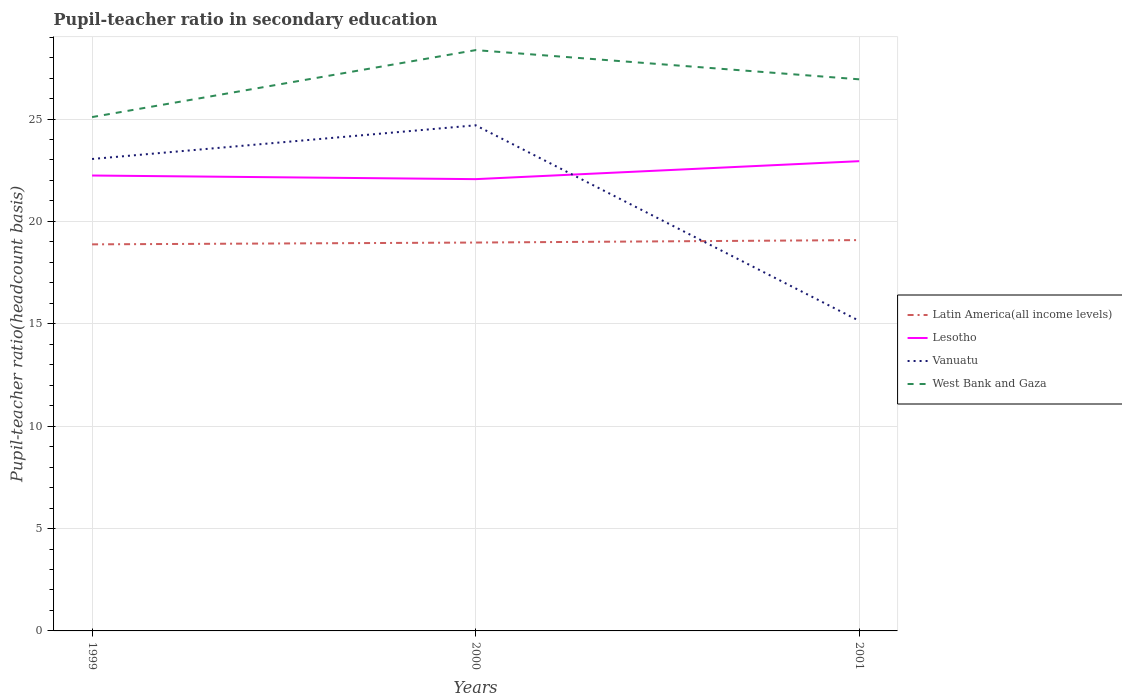Is the number of lines equal to the number of legend labels?
Offer a very short reply. Yes. Across all years, what is the maximum pupil-teacher ratio in secondary education in Latin America(all income levels)?
Your answer should be compact. 18.88. In which year was the pupil-teacher ratio in secondary education in Vanuatu maximum?
Offer a terse response. 2001. What is the total pupil-teacher ratio in secondary education in West Bank and Gaza in the graph?
Give a very brief answer. 1.43. What is the difference between the highest and the second highest pupil-teacher ratio in secondary education in Vanuatu?
Offer a very short reply. 9.55. How many lines are there?
Your answer should be compact. 4. How are the legend labels stacked?
Provide a succinct answer. Vertical. What is the title of the graph?
Ensure brevity in your answer.  Pupil-teacher ratio in secondary education. What is the label or title of the Y-axis?
Your response must be concise. Pupil-teacher ratio(headcount basis). What is the Pupil-teacher ratio(headcount basis) of Latin America(all income levels) in 1999?
Your answer should be very brief. 18.88. What is the Pupil-teacher ratio(headcount basis) in Lesotho in 1999?
Provide a short and direct response. 22.24. What is the Pupil-teacher ratio(headcount basis) in Vanuatu in 1999?
Make the answer very short. 23.05. What is the Pupil-teacher ratio(headcount basis) in West Bank and Gaza in 1999?
Keep it short and to the point. 25.1. What is the Pupil-teacher ratio(headcount basis) of Latin America(all income levels) in 2000?
Your answer should be compact. 18.97. What is the Pupil-teacher ratio(headcount basis) in Lesotho in 2000?
Give a very brief answer. 22.06. What is the Pupil-teacher ratio(headcount basis) in Vanuatu in 2000?
Ensure brevity in your answer.  24.7. What is the Pupil-teacher ratio(headcount basis) of West Bank and Gaza in 2000?
Your answer should be very brief. 28.37. What is the Pupil-teacher ratio(headcount basis) in Latin America(all income levels) in 2001?
Your answer should be compact. 19.09. What is the Pupil-teacher ratio(headcount basis) in Lesotho in 2001?
Your answer should be compact. 22.94. What is the Pupil-teacher ratio(headcount basis) of Vanuatu in 2001?
Keep it short and to the point. 15.14. What is the Pupil-teacher ratio(headcount basis) in West Bank and Gaza in 2001?
Offer a very short reply. 26.94. Across all years, what is the maximum Pupil-teacher ratio(headcount basis) in Latin America(all income levels)?
Your answer should be very brief. 19.09. Across all years, what is the maximum Pupil-teacher ratio(headcount basis) in Lesotho?
Provide a short and direct response. 22.94. Across all years, what is the maximum Pupil-teacher ratio(headcount basis) of Vanuatu?
Ensure brevity in your answer.  24.7. Across all years, what is the maximum Pupil-teacher ratio(headcount basis) of West Bank and Gaza?
Keep it short and to the point. 28.37. Across all years, what is the minimum Pupil-teacher ratio(headcount basis) in Latin America(all income levels)?
Provide a short and direct response. 18.88. Across all years, what is the minimum Pupil-teacher ratio(headcount basis) in Lesotho?
Provide a short and direct response. 22.06. Across all years, what is the minimum Pupil-teacher ratio(headcount basis) in Vanuatu?
Your answer should be very brief. 15.14. Across all years, what is the minimum Pupil-teacher ratio(headcount basis) in West Bank and Gaza?
Offer a very short reply. 25.1. What is the total Pupil-teacher ratio(headcount basis) of Latin America(all income levels) in the graph?
Your response must be concise. 56.94. What is the total Pupil-teacher ratio(headcount basis) in Lesotho in the graph?
Your answer should be very brief. 67.25. What is the total Pupil-teacher ratio(headcount basis) of Vanuatu in the graph?
Your response must be concise. 62.89. What is the total Pupil-teacher ratio(headcount basis) of West Bank and Gaza in the graph?
Your answer should be compact. 80.4. What is the difference between the Pupil-teacher ratio(headcount basis) of Latin America(all income levels) in 1999 and that in 2000?
Make the answer very short. -0.09. What is the difference between the Pupil-teacher ratio(headcount basis) in Lesotho in 1999 and that in 2000?
Your answer should be compact. 0.18. What is the difference between the Pupil-teacher ratio(headcount basis) in Vanuatu in 1999 and that in 2000?
Make the answer very short. -1.65. What is the difference between the Pupil-teacher ratio(headcount basis) in West Bank and Gaza in 1999 and that in 2000?
Offer a very short reply. -3.27. What is the difference between the Pupil-teacher ratio(headcount basis) in Latin America(all income levels) in 1999 and that in 2001?
Provide a succinct answer. -0.21. What is the difference between the Pupil-teacher ratio(headcount basis) of Lesotho in 1999 and that in 2001?
Offer a very short reply. -0.7. What is the difference between the Pupil-teacher ratio(headcount basis) in Vanuatu in 1999 and that in 2001?
Provide a succinct answer. 7.9. What is the difference between the Pupil-teacher ratio(headcount basis) in West Bank and Gaza in 1999 and that in 2001?
Your answer should be compact. -1.84. What is the difference between the Pupil-teacher ratio(headcount basis) of Latin America(all income levels) in 2000 and that in 2001?
Keep it short and to the point. -0.12. What is the difference between the Pupil-teacher ratio(headcount basis) in Lesotho in 2000 and that in 2001?
Offer a very short reply. -0.88. What is the difference between the Pupil-teacher ratio(headcount basis) of Vanuatu in 2000 and that in 2001?
Keep it short and to the point. 9.55. What is the difference between the Pupil-teacher ratio(headcount basis) of West Bank and Gaza in 2000 and that in 2001?
Offer a terse response. 1.43. What is the difference between the Pupil-teacher ratio(headcount basis) in Latin America(all income levels) in 1999 and the Pupil-teacher ratio(headcount basis) in Lesotho in 2000?
Give a very brief answer. -3.18. What is the difference between the Pupil-teacher ratio(headcount basis) in Latin America(all income levels) in 1999 and the Pupil-teacher ratio(headcount basis) in Vanuatu in 2000?
Your response must be concise. -5.82. What is the difference between the Pupil-teacher ratio(headcount basis) in Latin America(all income levels) in 1999 and the Pupil-teacher ratio(headcount basis) in West Bank and Gaza in 2000?
Make the answer very short. -9.49. What is the difference between the Pupil-teacher ratio(headcount basis) in Lesotho in 1999 and the Pupil-teacher ratio(headcount basis) in Vanuatu in 2000?
Your response must be concise. -2.45. What is the difference between the Pupil-teacher ratio(headcount basis) in Lesotho in 1999 and the Pupil-teacher ratio(headcount basis) in West Bank and Gaza in 2000?
Provide a short and direct response. -6.12. What is the difference between the Pupil-teacher ratio(headcount basis) of Vanuatu in 1999 and the Pupil-teacher ratio(headcount basis) of West Bank and Gaza in 2000?
Provide a short and direct response. -5.32. What is the difference between the Pupil-teacher ratio(headcount basis) of Latin America(all income levels) in 1999 and the Pupil-teacher ratio(headcount basis) of Lesotho in 2001?
Offer a very short reply. -4.06. What is the difference between the Pupil-teacher ratio(headcount basis) in Latin America(all income levels) in 1999 and the Pupil-teacher ratio(headcount basis) in Vanuatu in 2001?
Give a very brief answer. 3.74. What is the difference between the Pupil-teacher ratio(headcount basis) in Latin America(all income levels) in 1999 and the Pupil-teacher ratio(headcount basis) in West Bank and Gaza in 2001?
Give a very brief answer. -8.06. What is the difference between the Pupil-teacher ratio(headcount basis) of Lesotho in 1999 and the Pupil-teacher ratio(headcount basis) of Vanuatu in 2001?
Your answer should be compact. 7.1. What is the difference between the Pupil-teacher ratio(headcount basis) in Lesotho in 1999 and the Pupil-teacher ratio(headcount basis) in West Bank and Gaza in 2001?
Your answer should be compact. -4.7. What is the difference between the Pupil-teacher ratio(headcount basis) in Vanuatu in 1999 and the Pupil-teacher ratio(headcount basis) in West Bank and Gaza in 2001?
Give a very brief answer. -3.89. What is the difference between the Pupil-teacher ratio(headcount basis) of Latin America(all income levels) in 2000 and the Pupil-teacher ratio(headcount basis) of Lesotho in 2001?
Your answer should be compact. -3.97. What is the difference between the Pupil-teacher ratio(headcount basis) in Latin America(all income levels) in 2000 and the Pupil-teacher ratio(headcount basis) in Vanuatu in 2001?
Your answer should be compact. 3.82. What is the difference between the Pupil-teacher ratio(headcount basis) of Latin America(all income levels) in 2000 and the Pupil-teacher ratio(headcount basis) of West Bank and Gaza in 2001?
Ensure brevity in your answer.  -7.97. What is the difference between the Pupil-teacher ratio(headcount basis) of Lesotho in 2000 and the Pupil-teacher ratio(headcount basis) of Vanuatu in 2001?
Ensure brevity in your answer.  6.92. What is the difference between the Pupil-teacher ratio(headcount basis) of Lesotho in 2000 and the Pupil-teacher ratio(headcount basis) of West Bank and Gaza in 2001?
Provide a succinct answer. -4.88. What is the difference between the Pupil-teacher ratio(headcount basis) of Vanuatu in 2000 and the Pupil-teacher ratio(headcount basis) of West Bank and Gaza in 2001?
Offer a very short reply. -2.24. What is the average Pupil-teacher ratio(headcount basis) of Latin America(all income levels) per year?
Provide a short and direct response. 18.98. What is the average Pupil-teacher ratio(headcount basis) in Lesotho per year?
Offer a very short reply. 22.42. What is the average Pupil-teacher ratio(headcount basis) in Vanuatu per year?
Keep it short and to the point. 20.96. What is the average Pupil-teacher ratio(headcount basis) in West Bank and Gaza per year?
Provide a short and direct response. 26.8. In the year 1999, what is the difference between the Pupil-teacher ratio(headcount basis) in Latin America(all income levels) and Pupil-teacher ratio(headcount basis) in Lesotho?
Make the answer very short. -3.36. In the year 1999, what is the difference between the Pupil-teacher ratio(headcount basis) of Latin America(all income levels) and Pupil-teacher ratio(headcount basis) of Vanuatu?
Give a very brief answer. -4.17. In the year 1999, what is the difference between the Pupil-teacher ratio(headcount basis) in Latin America(all income levels) and Pupil-teacher ratio(headcount basis) in West Bank and Gaza?
Your answer should be very brief. -6.22. In the year 1999, what is the difference between the Pupil-teacher ratio(headcount basis) in Lesotho and Pupil-teacher ratio(headcount basis) in Vanuatu?
Give a very brief answer. -0.81. In the year 1999, what is the difference between the Pupil-teacher ratio(headcount basis) in Lesotho and Pupil-teacher ratio(headcount basis) in West Bank and Gaza?
Keep it short and to the point. -2.85. In the year 1999, what is the difference between the Pupil-teacher ratio(headcount basis) in Vanuatu and Pupil-teacher ratio(headcount basis) in West Bank and Gaza?
Make the answer very short. -2.05. In the year 2000, what is the difference between the Pupil-teacher ratio(headcount basis) in Latin America(all income levels) and Pupil-teacher ratio(headcount basis) in Lesotho?
Offer a very short reply. -3.1. In the year 2000, what is the difference between the Pupil-teacher ratio(headcount basis) of Latin America(all income levels) and Pupil-teacher ratio(headcount basis) of Vanuatu?
Your response must be concise. -5.73. In the year 2000, what is the difference between the Pupil-teacher ratio(headcount basis) of Latin America(all income levels) and Pupil-teacher ratio(headcount basis) of West Bank and Gaza?
Offer a very short reply. -9.4. In the year 2000, what is the difference between the Pupil-teacher ratio(headcount basis) in Lesotho and Pupil-teacher ratio(headcount basis) in Vanuatu?
Keep it short and to the point. -2.63. In the year 2000, what is the difference between the Pupil-teacher ratio(headcount basis) in Lesotho and Pupil-teacher ratio(headcount basis) in West Bank and Gaza?
Offer a terse response. -6.3. In the year 2000, what is the difference between the Pupil-teacher ratio(headcount basis) of Vanuatu and Pupil-teacher ratio(headcount basis) of West Bank and Gaza?
Your answer should be compact. -3.67. In the year 2001, what is the difference between the Pupil-teacher ratio(headcount basis) in Latin America(all income levels) and Pupil-teacher ratio(headcount basis) in Lesotho?
Offer a very short reply. -3.85. In the year 2001, what is the difference between the Pupil-teacher ratio(headcount basis) of Latin America(all income levels) and Pupil-teacher ratio(headcount basis) of Vanuatu?
Provide a short and direct response. 3.94. In the year 2001, what is the difference between the Pupil-teacher ratio(headcount basis) in Latin America(all income levels) and Pupil-teacher ratio(headcount basis) in West Bank and Gaza?
Offer a very short reply. -7.85. In the year 2001, what is the difference between the Pupil-teacher ratio(headcount basis) in Lesotho and Pupil-teacher ratio(headcount basis) in Vanuatu?
Ensure brevity in your answer.  7.8. In the year 2001, what is the difference between the Pupil-teacher ratio(headcount basis) in Lesotho and Pupil-teacher ratio(headcount basis) in West Bank and Gaza?
Your answer should be compact. -4. In the year 2001, what is the difference between the Pupil-teacher ratio(headcount basis) of Vanuatu and Pupil-teacher ratio(headcount basis) of West Bank and Gaza?
Keep it short and to the point. -11.8. What is the ratio of the Pupil-teacher ratio(headcount basis) in Latin America(all income levels) in 1999 to that in 2000?
Provide a short and direct response. 1. What is the ratio of the Pupil-teacher ratio(headcount basis) of Vanuatu in 1999 to that in 2000?
Ensure brevity in your answer.  0.93. What is the ratio of the Pupil-teacher ratio(headcount basis) in West Bank and Gaza in 1999 to that in 2000?
Offer a very short reply. 0.88. What is the ratio of the Pupil-teacher ratio(headcount basis) of Lesotho in 1999 to that in 2001?
Your answer should be very brief. 0.97. What is the ratio of the Pupil-teacher ratio(headcount basis) in Vanuatu in 1999 to that in 2001?
Offer a very short reply. 1.52. What is the ratio of the Pupil-teacher ratio(headcount basis) in West Bank and Gaza in 1999 to that in 2001?
Keep it short and to the point. 0.93. What is the ratio of the Pupil-teacher ratio(headcount basis) in Lesotho in 2000 to that in 2001?
Keep it short and to the point. 0.96. What is the ratio of the Pupil-teacher ratio(headcount basis) in Vanuatu in 2000 to that in 2001?
Ensure brevity in your answer.  1.63. What is the ratio of the Pupil-teacher ratio(headcount basis) in West Bank and Gaza in 2000 to that in 2001?
Offer a terse response. 1.05. What is the difference between the highest and the second highest Pupil-teacher ratio(headcount basis) of Latin America(all income levels)?
Offer a terse response. 0.12. What is the difference between the highest and the second highest Pupil-teacher ratio(headcount basis) of Lesotho?
Offer a very short reply. 0.7. What is the difference between the highest and the second highest Pupil-teacher ratio(headcount basis) in Vanuatu?
Your response must be concise. 1.65. What is the difference between the highest and the second highest Pupil-teacher ratio(headcount basis) in West Bank and Gaza?
Offer a very short reply. 1.43. What is the difference between the highest and the lowest Pupil-teacher ratio(headcount basis) of Latin America(all income levels)?
Keep it short and to the point. 0.21. What is the difference between the highest and the lowest Pupil-teacher ratio(headcount basis) in Lesotho?
Ensure brevity in your answer.  0.88. What is the difference between the highest and the lowest Pupil-teacher ratio(headcount basis) in Vanuatu?
Your answer should be compact. 9.55. What is the difference between the highest and the lowest Pupil-teacher ratio(headcount basis) in West Bank and Gaza?
Ensure brevity in your answer.  3.27. 